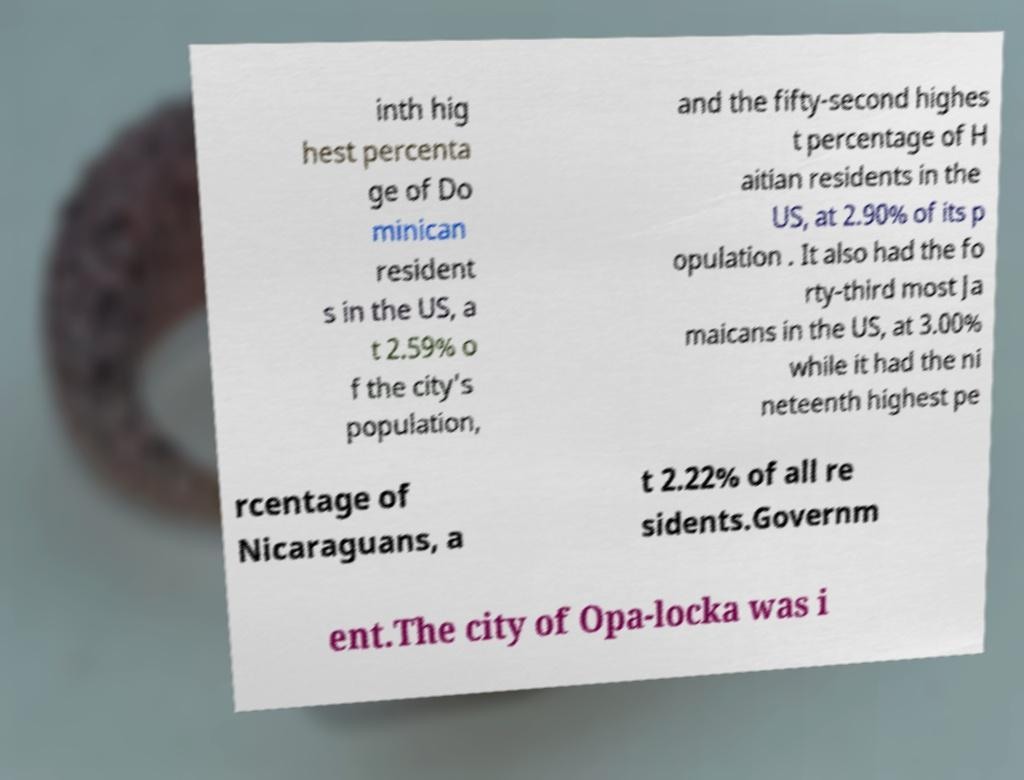Can you read and provide the text displayed in the image?This photo seems to have some interesting text. Can you extract and type it out for me? inth hig hest percenta ge of Do minican resident s in the US, a t 2.59% o f the city's population, and the fifty-second highes t percentage of H aitian residents in the US, at 2.90% of its p opulation . It also had the fo rty-third most Ja maicans in the US, at 3.00% while it had the ni neteenth highest pe rcentage of Nicaraguans, a t 2.22% of all re sidents.Governm ent.The city of Opa-locka was i 